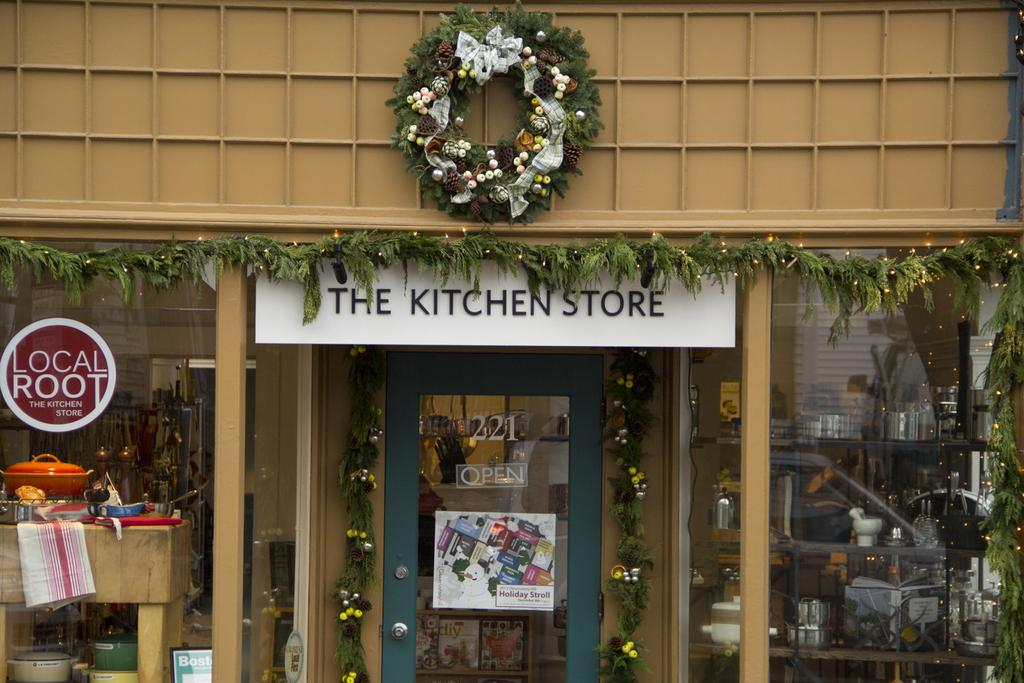<image>
Offer a succinct explanation of the picture presented. A storefront with a sign that says The Kitchen Store over the door. 